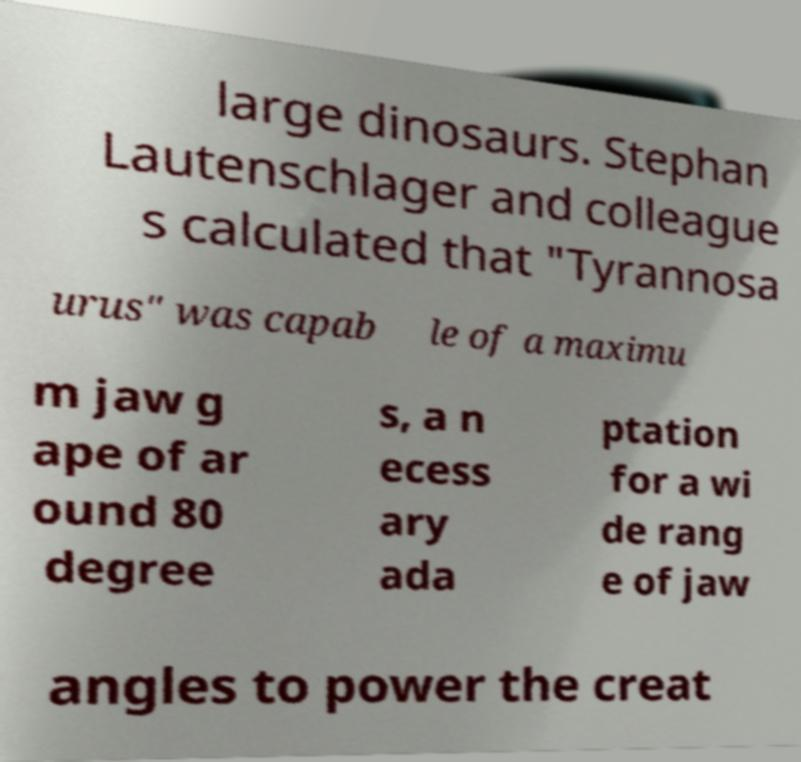Could you assist in decoding the text presented in this image and type it out clearly? large dinosaurs. Stephan Lautenschlager and colleague s calculated that "Tyrannosa urus" was capab le of a maximu m jaw g ape of ar ound 80 degree s, a n ecess ary ada ptation for a wi de rang e of jaw angles to power the creat 